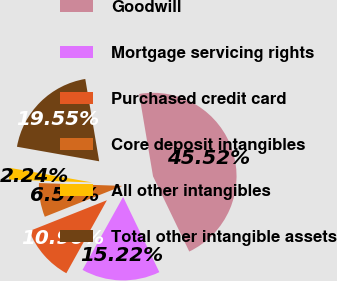Convert chart to OTSL. <chart><loc_0><loc_0><loc_500><loc_500><pie_chart><fcel>Goodwill<fcel>Mortgage servicing rights<fcel>Purchased credit card<fcel>Core deposit intangibles<fcel>All other intangibles<fcel>Total other intangible assets<nl><fcel>45.52%<fcel>15.22%<fcel>10.9%<fcel>6.57%<fcel>2.24%<fcel>19.55%<nl></chart> 